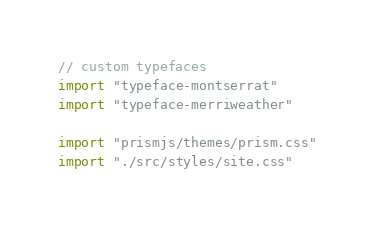<code> <loc_0><loc_0><loc_500><loc_500><_JavaScript_>// custom typefaces
import "typeface-montserrat"
import "typeface-merriweather"

import "prismjs/themes/prism.css"
import "./src/styles/site.css"
</code> 